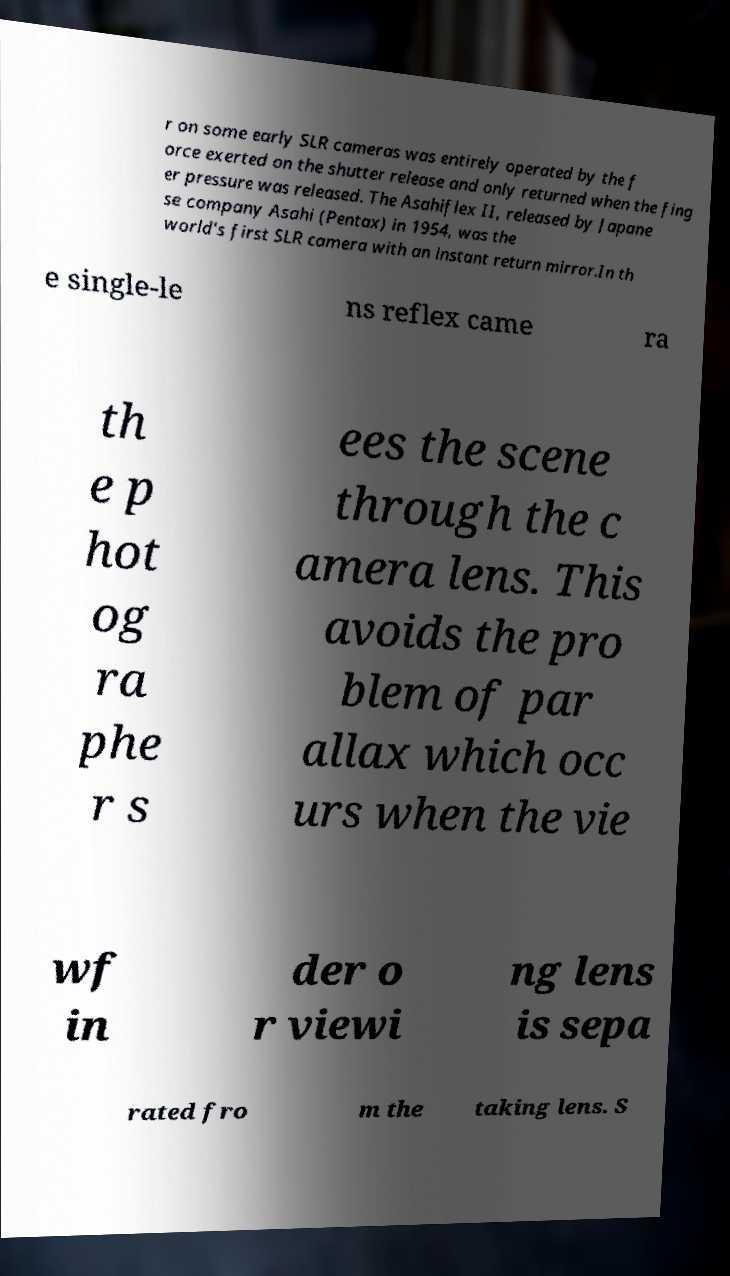Could you assist in decoding the text presented in this image and type it out clearly? r on some early SLR cameras was entirely operated by the f orce exerted on the shutter release and only returned when the fing er pressure was released. The Asahiflex II, released by Japane se company Asahi (Pentax) in 1954, was the world's first SLR camera with an instant return mirror.In th e single-le ns reflex came ra th e p hot og ra phe r s ees the scene through the c amera lens. This avoids the pro blem of par allax which occ urs when the vie wf in der o r viewi ng lens is sepa rated fro m the taking lens. S 